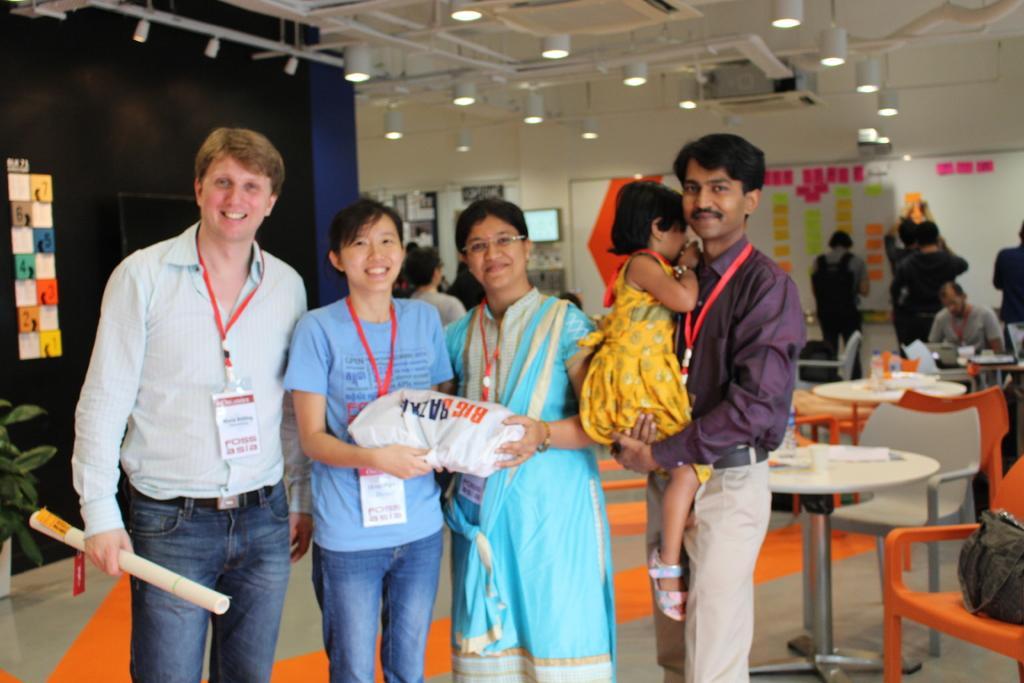Could you give a brief overview of what you see in this image? Here we can see four people standing together and the person in the right is having a baby in his hand and in middle we can see they are holding a cover at the left side we can see the man holding a chart and behind them we can see tables and chairs and some people are sitting on the chairs and some are standing 